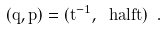<formula> <loc_0><loc_0><loc_500><loc_500>( q , p ) = ( t ^ { - 1 } , \ h a l f t ) \ .</formula> 